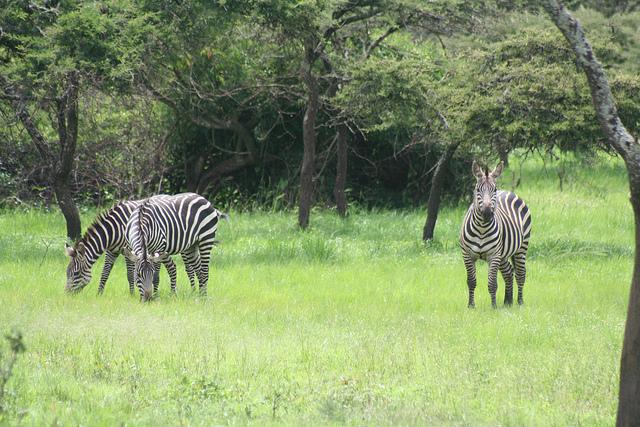How many zebras are there?
Write a very short answer. 3. Is this daytime?
Keep it brief. Yes. Is there a goose?
Keep it brief. No. What are the zebras standing on?
Short answer required. Grass. 